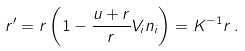<formula> <loc_0><loc_0><loc_500><loc_500>r ^ { \prime } = r \left ( 1 - \frac { u + r } { r } V _ { i } n _ { i } \right ) = K ^ { - 1 } r \, .</formula> 